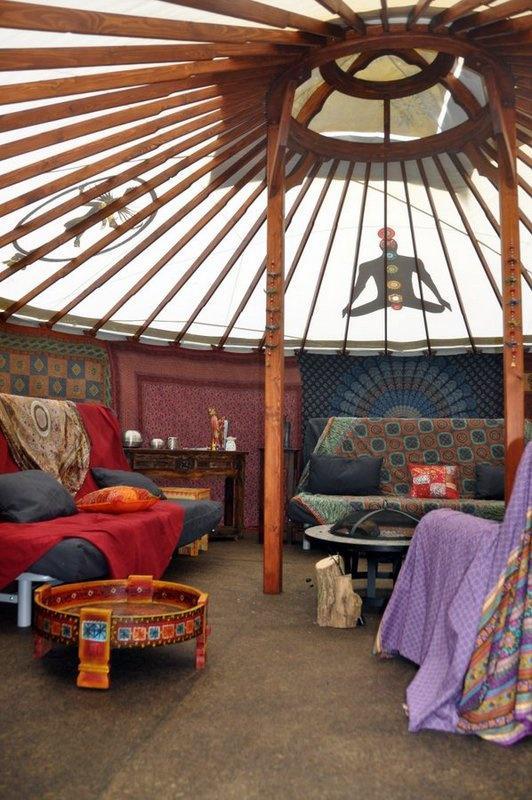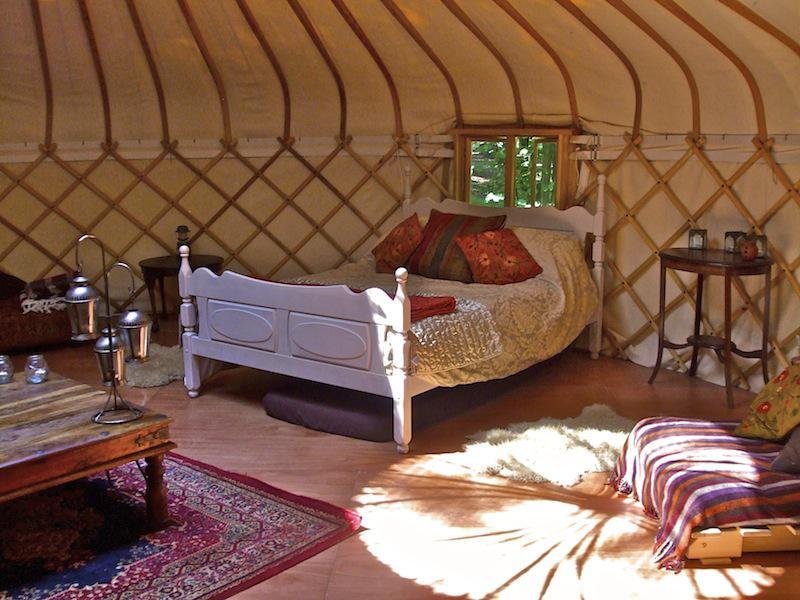The first image is the image on the left, the second image is the image on the right. Analyze the images presented: Is the assertion "There is a bed in the image on the right." valid? Answer yes or no. Yes. 